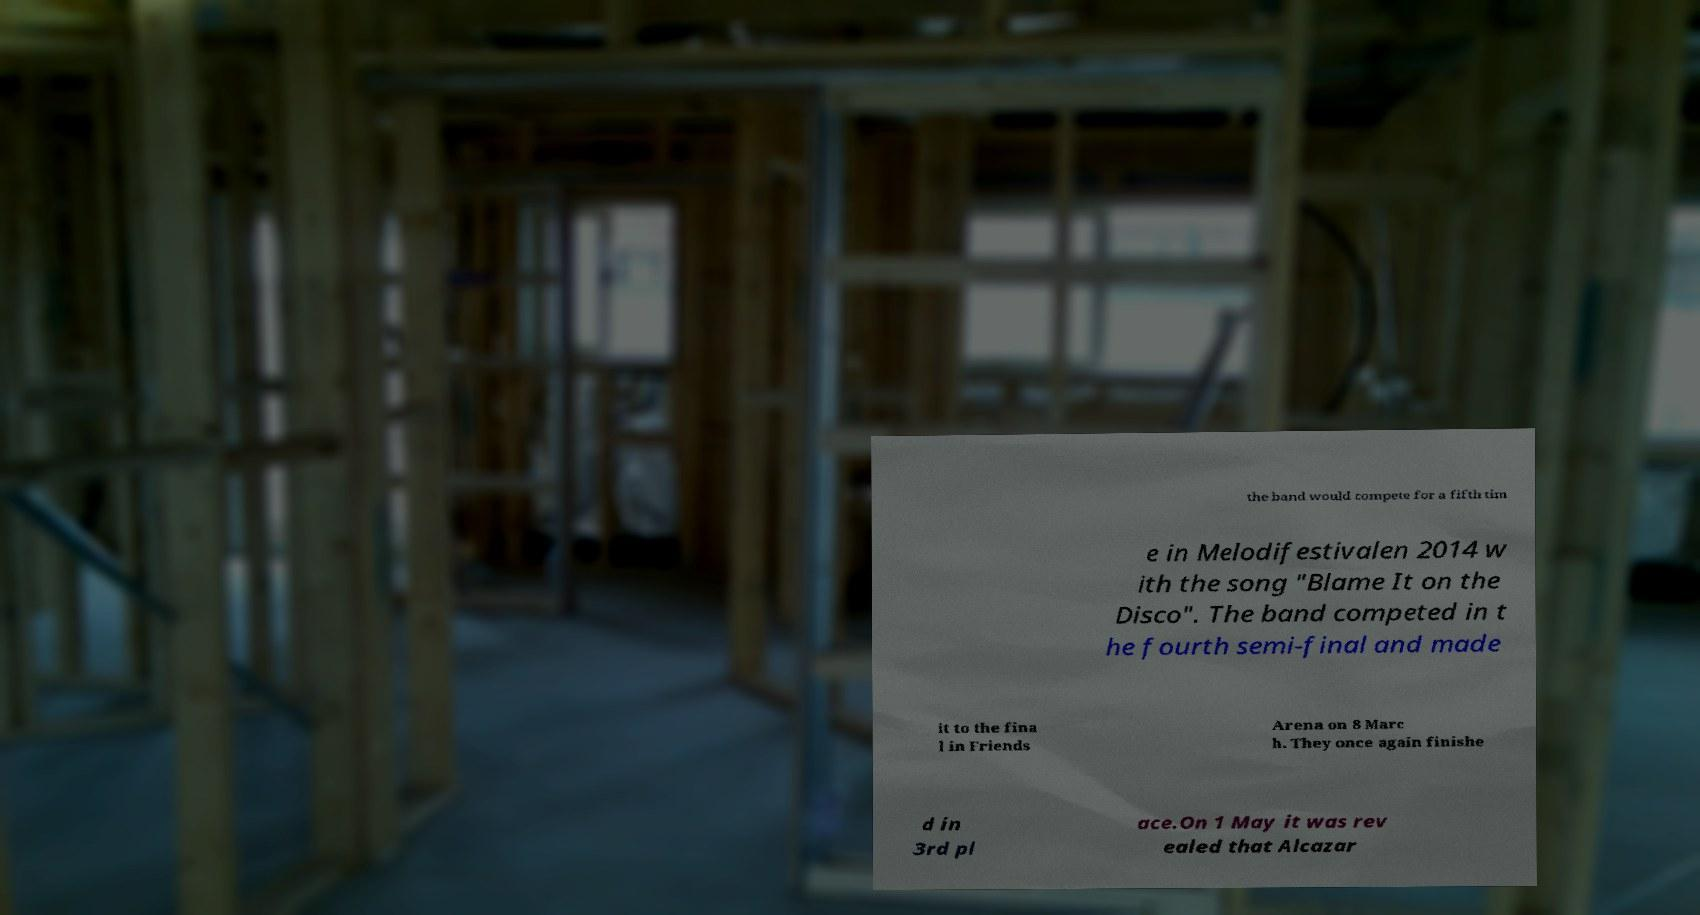I need the written content from this picture converted into text. Can you do that? the band would compete for a fifth tim e in Melodifestivalen 2014 w ith the song "Blame It on the Disco". The band competed in t he fourth semi-final and made it to the fina l in Friends Arena on 8 Marc h. They once again finishe d in 3rd pl ace.On 1 May it was rev ealed that Alcazar 